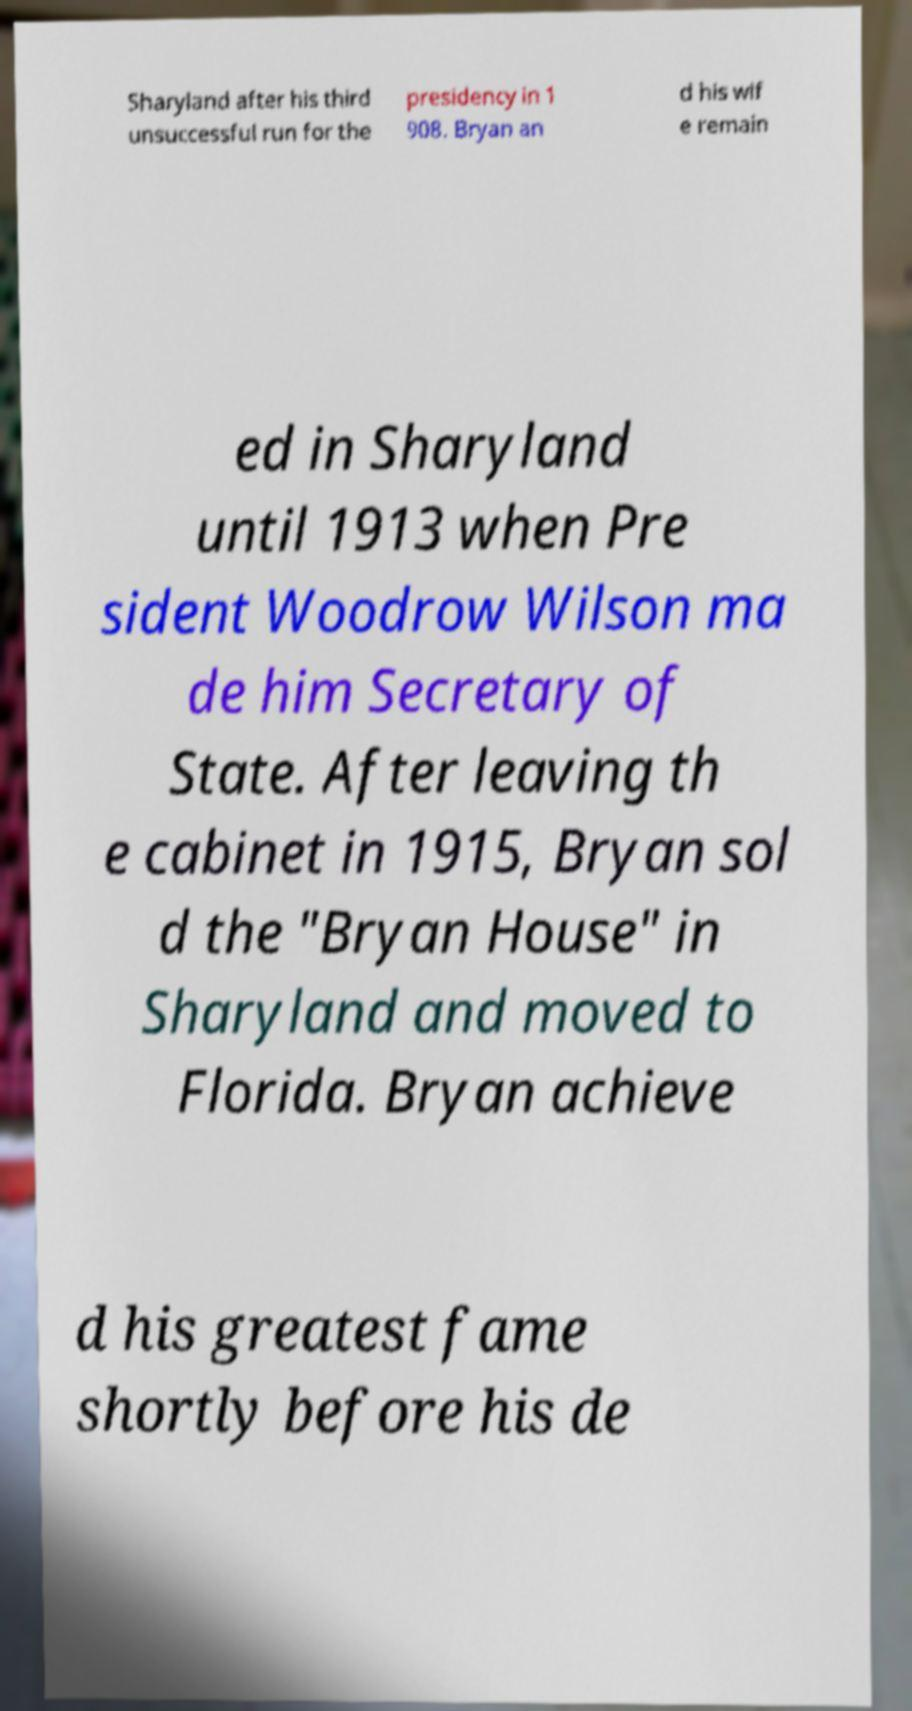What messages or text are displayed in this image? I need them in a readable, typed format. Sharyland after his third unsuccessful run for the presidency in 1 908. Bryan an d his wif e remain ed in Sharyland until 1913 when Pre sident Woodrow Wilson ma de him Secretary of State. After leaving th e cabinet in 1915, Bryan sol d the "Bryan House" in Sharyland and moved to Florida. Bryan achieve d his greatest fame shortly before his de 